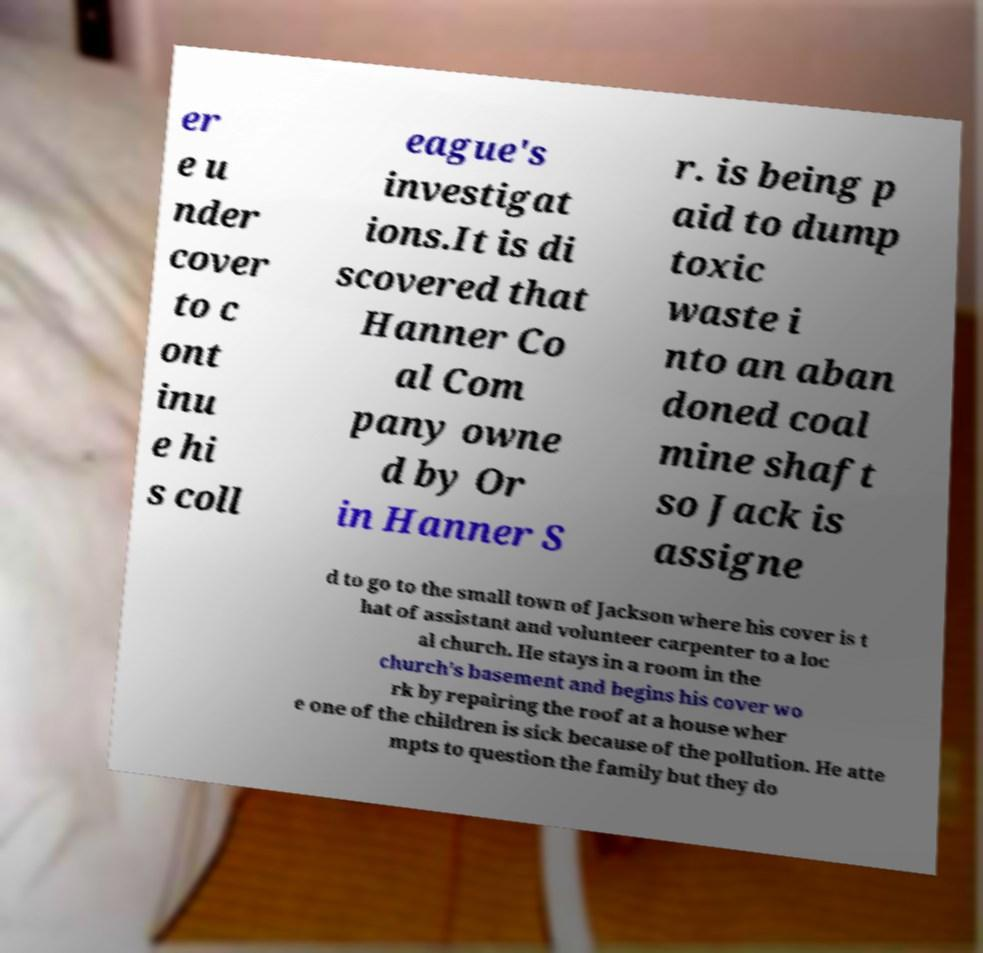Please read and relay the text visible in this image. What does it say? er e u nder cover to c ont inu e hi s coll eague's investigat ions.It is di scovered that Hanner Co al Com pany owne d by Or in Hanner S r. is being p aid to dump toxic waste i nto an aban doned coal mine shaft so Jack is assigne d to go to the small town of Jackson where his cover is t hat of assistant and volunteer carpenter to a loc al church. He stays in a room in the church's basement and begins his cover wo rk by repairing the roof at a house wher e one of the children is sick because of the pollution. He atte mpts to question the family but they do 